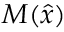<formula> <loc_0><loc_0><loc_500><loc_500>M ( { \hat { x } } )</formula> 